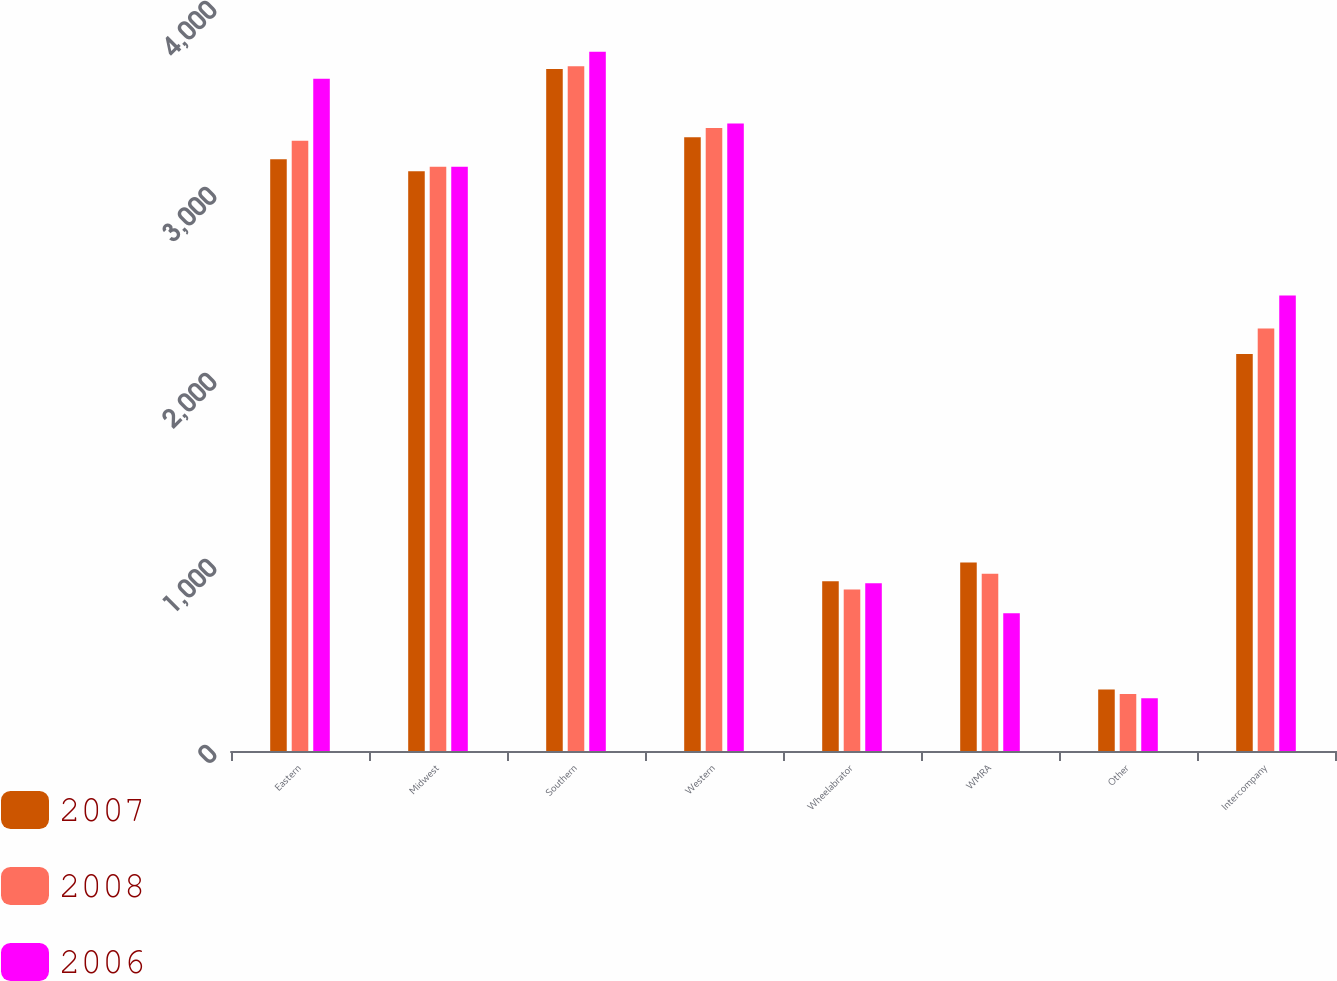Convert chart. <chart><loc_0><loc_0><loc_500><loc_500><stacked_bar_chart><ecel><fcel>Eastern<fcel>Midwest<fcel>Southern<fcel>Western<fcel>Wheelabrator<fcel>WMRA<fcel>Other<fcel>Intercompany<nl><fcel>2007<fcel>3182<fcel>3117<fcel>3667<fcel>3300<fcel>912<fcel>1014<fcel>330<fcel>2134<nl><fcel>2008<fcel>3281<fcel>3141<fcel>3681<fcel>3350<fcel>868<fcel>953<fcel>307<fcel>2271<nl><fcel>2006<fcel>3614<fcel>3141<fcel>3759<fcel>3373<fcel>902<fcel>740<fcel>283<fcel>2449<nl></chart> 